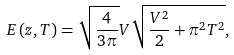Convert formula to latex. <formula><loc_0><loc_0><loc_500><loc_500>E \left ( z , T \right ) = \sqrt { \frac { 4 } { 3 \pi } } V \sqrt { \frac { V ^ { 2 } } { 2 } + \pi ^ { 2 } T ^ { 2 } } ,</formula> 